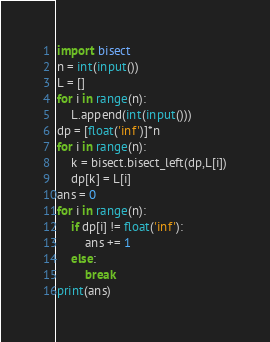Convert code to text. <code><loc_0><loc_0><loc_500><loc_500><_Python_>import bisect
n = int(input())
L = []
for i in range(n):
    L.append(int(input()))
dp = [float('inf')]*n
for i in range(n):
    k = bisect.bisect_left(dp,L[i])
    dp[k] = L[i]
ans = 0
for i in range(n):
    if dp[i] != float('inf'):
        ans += 1
    else:
        break
print(ans)
</code> 